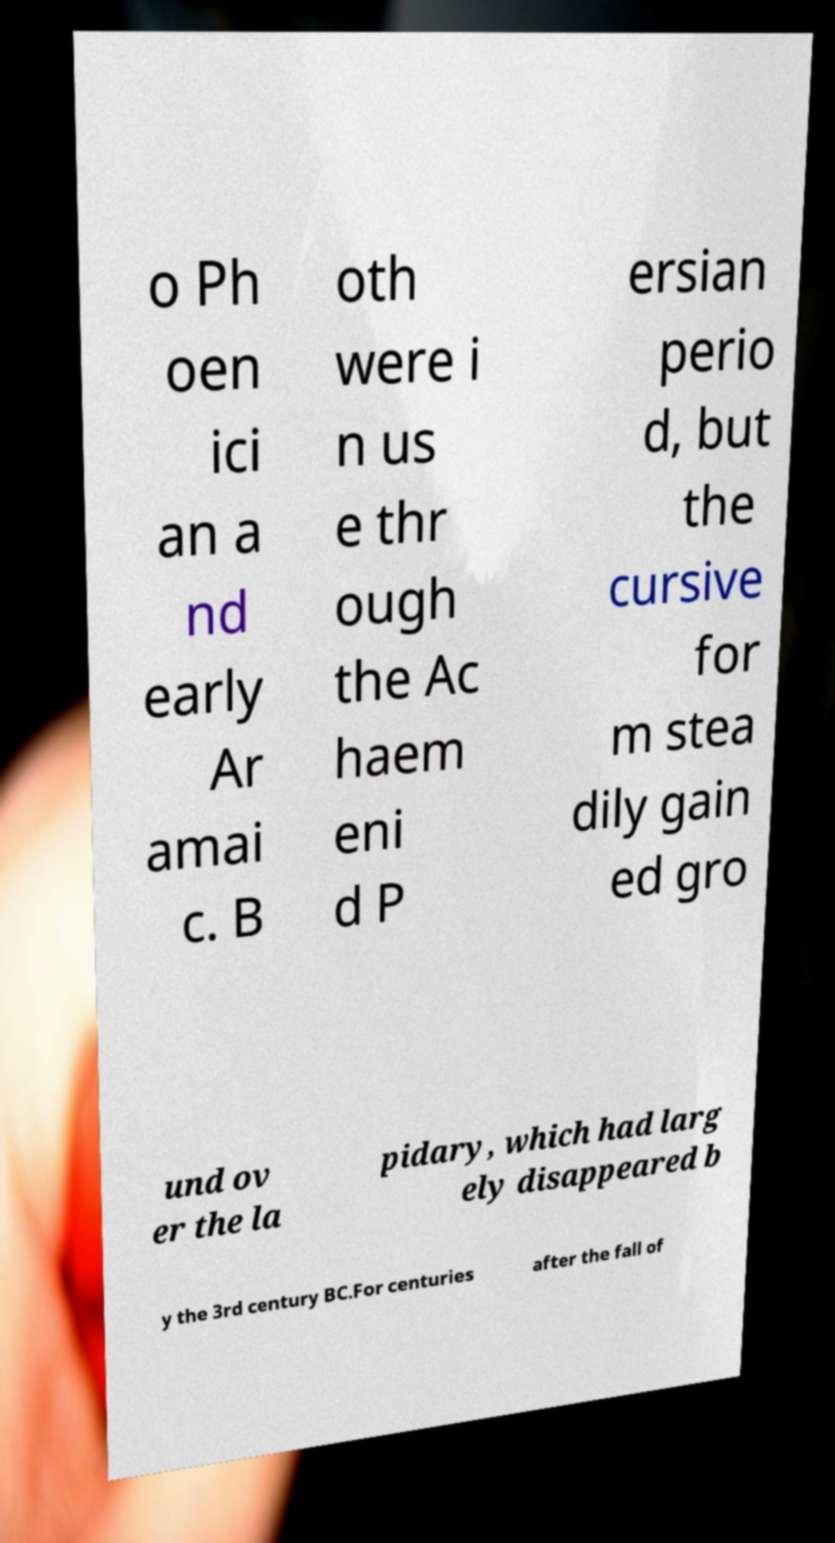There's text embedded in this image that I need extracted. Can you transcribe it verbatim? o Ph oen ici an a nd early Ar amai c. B oth were i n us e thr ough the Ac haem eni d P ersian perio d, but the cursive for m stea dily gain ed gro und ov er the la pidary, which had larg ely disappeared b y the 3rd century BC.For centuries after the fall of 